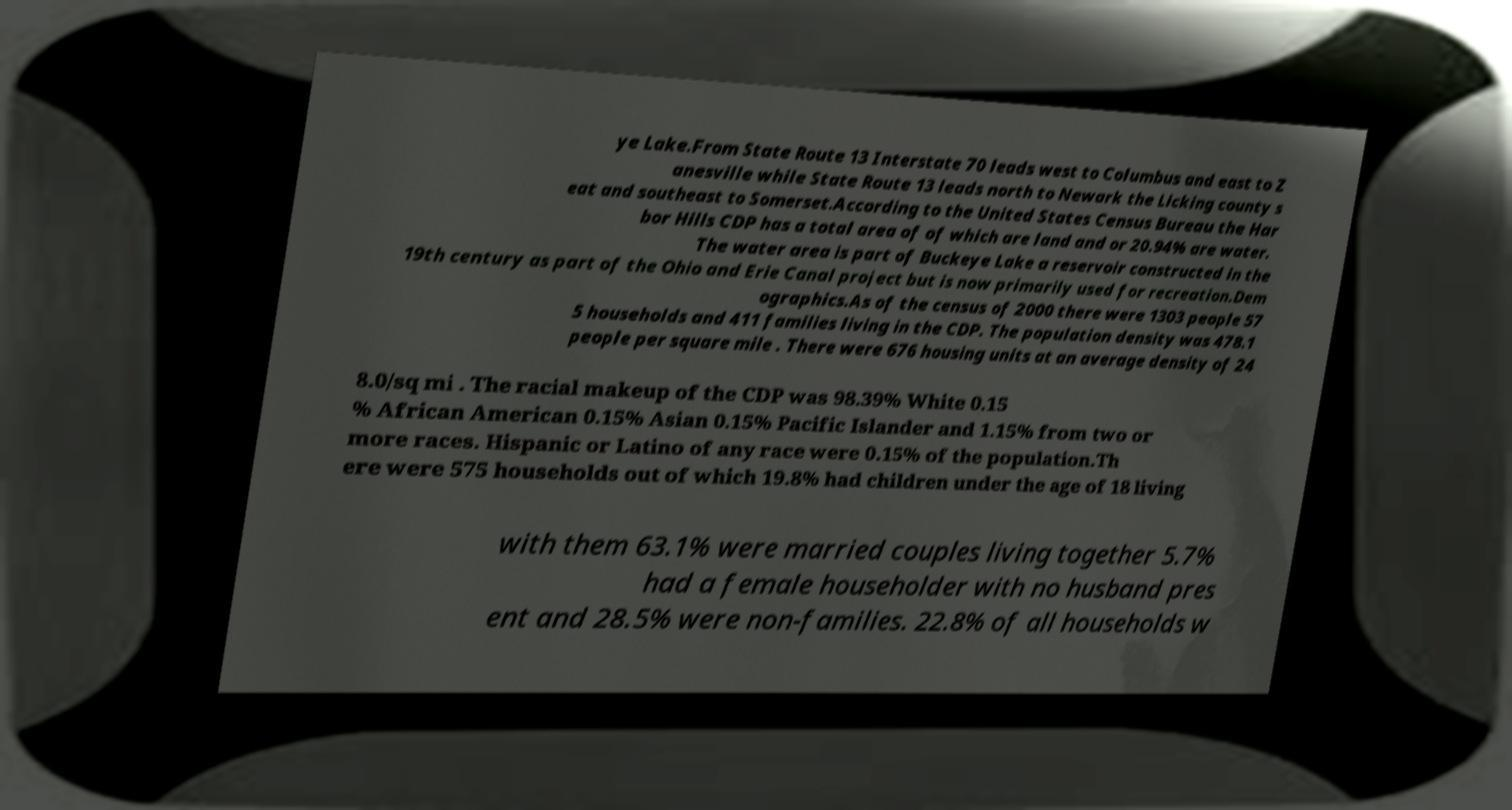Can you read and provide the text displayed in the image?This photo seems to have some interesting text. Can you extract and type it out for me? ye Lake.From State Route 13 Interstate 70 leads west to Columbus and east to Z anesville while State Route 13 leads north to Newark the Licking county s eat and southeast to Somerset.According to the United States Census Bureau the Har bor Hills CDP has a total area of of which are land and or 20.94% are water. The water area is part of Buckeye Lake a reservoir constructed in the 19th century as part of the Ohio and Erie Canal project but is now primarily used for recreation.Dem ographics.As of the census of 2000 there were 1303 people 57 5 households and 411 families living in the CDP. The population density was 478.1 people per square mile . There were 676 housing units at an average density of 24 8.0/sq mi . The racial makeup of the CDP was 98.39% White 0.15 % African American 0.15% Asian 0.15% Pacific Islander and 1.15% from two or more races. Hispanic or Latino of any race were 0.15% of the population.Th ere were 575 households out of which 19.8% had children under the age of 18 living with them 63.1% were married couples living together 5.7% had a female householder with no husband pres ent and 28.5% were non-families. 22.8% of all households w 